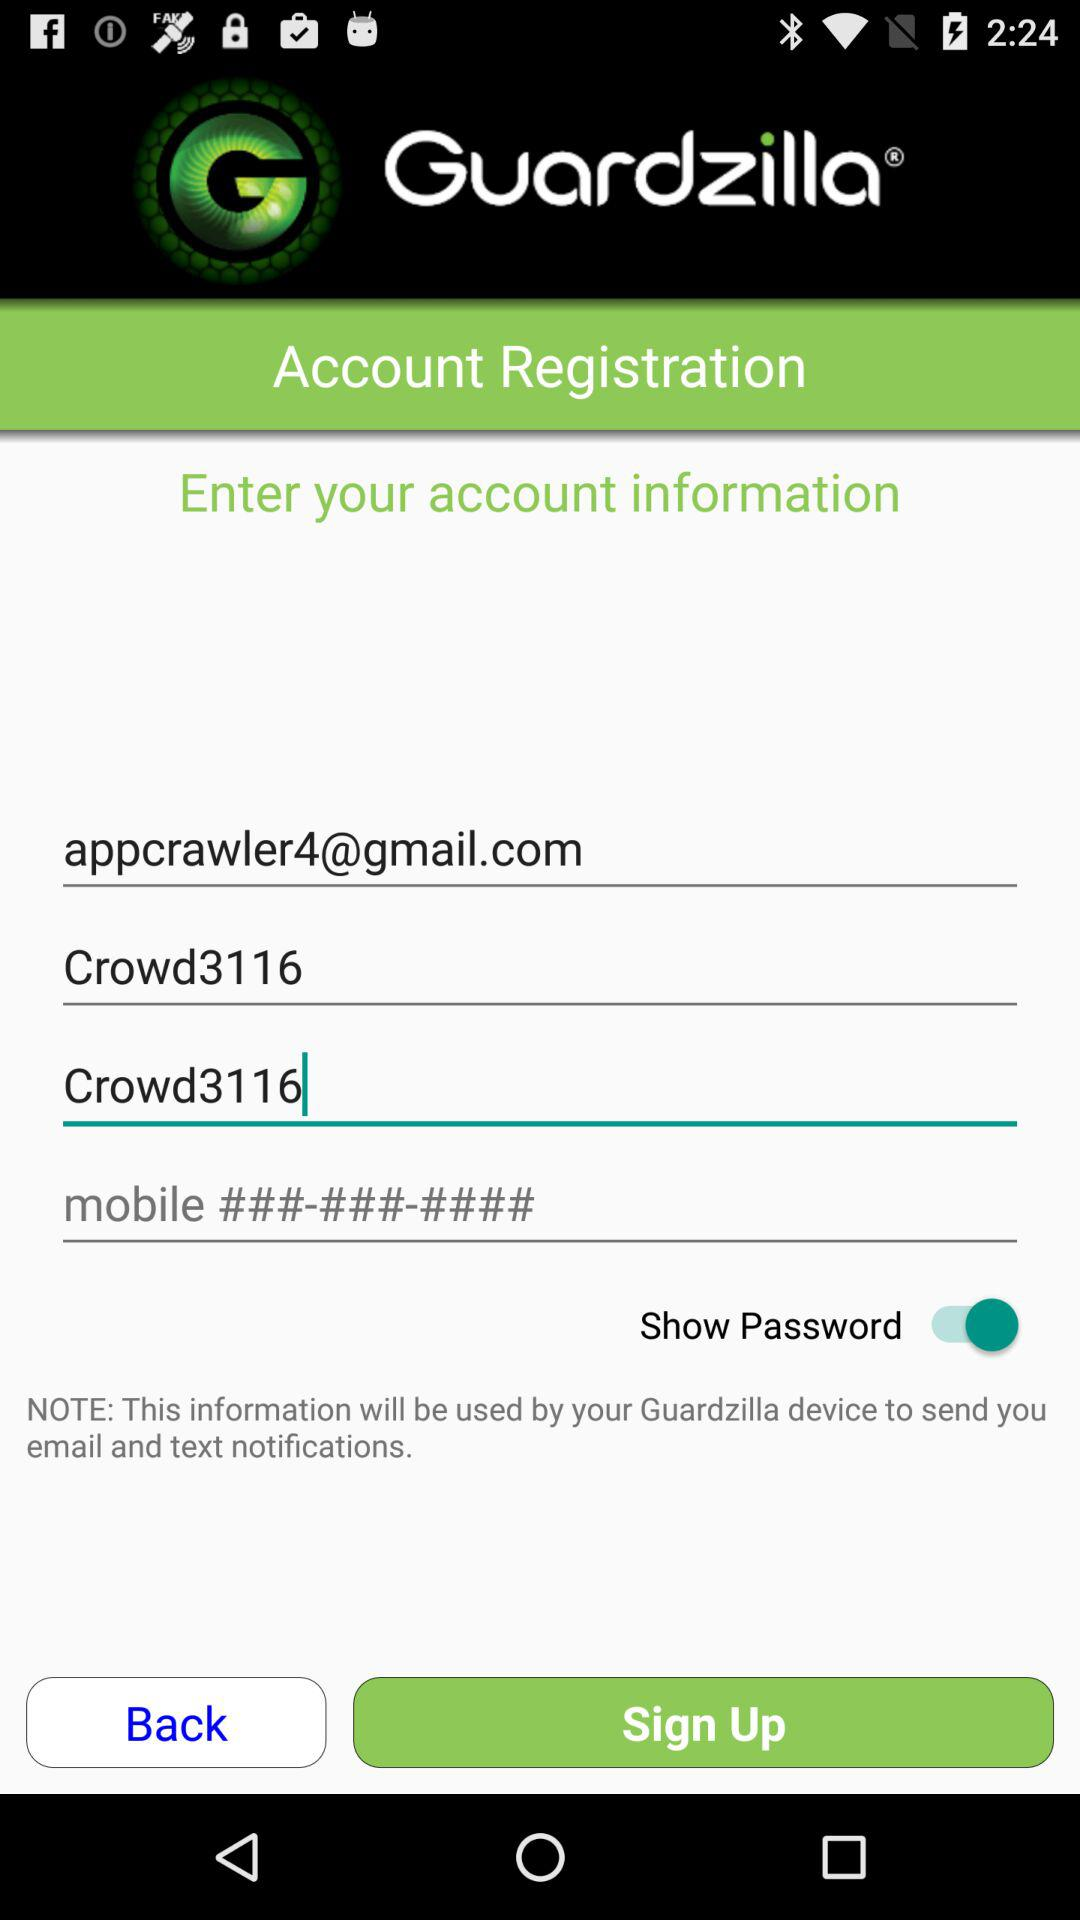How many text fields are there in the account registration form?
Answer the question using a single word or phrase. 4 